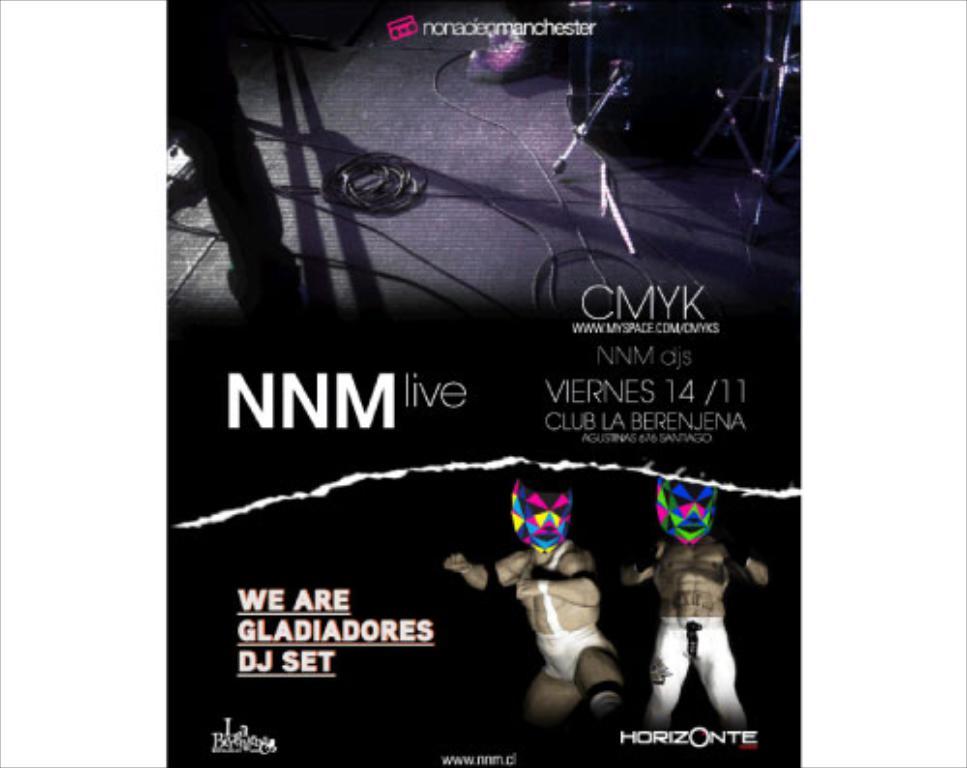What is the premier date?
Your answer should be compact. 14/11. Where is this taking place?
Provide a short and direct response. Club la berenjena. 